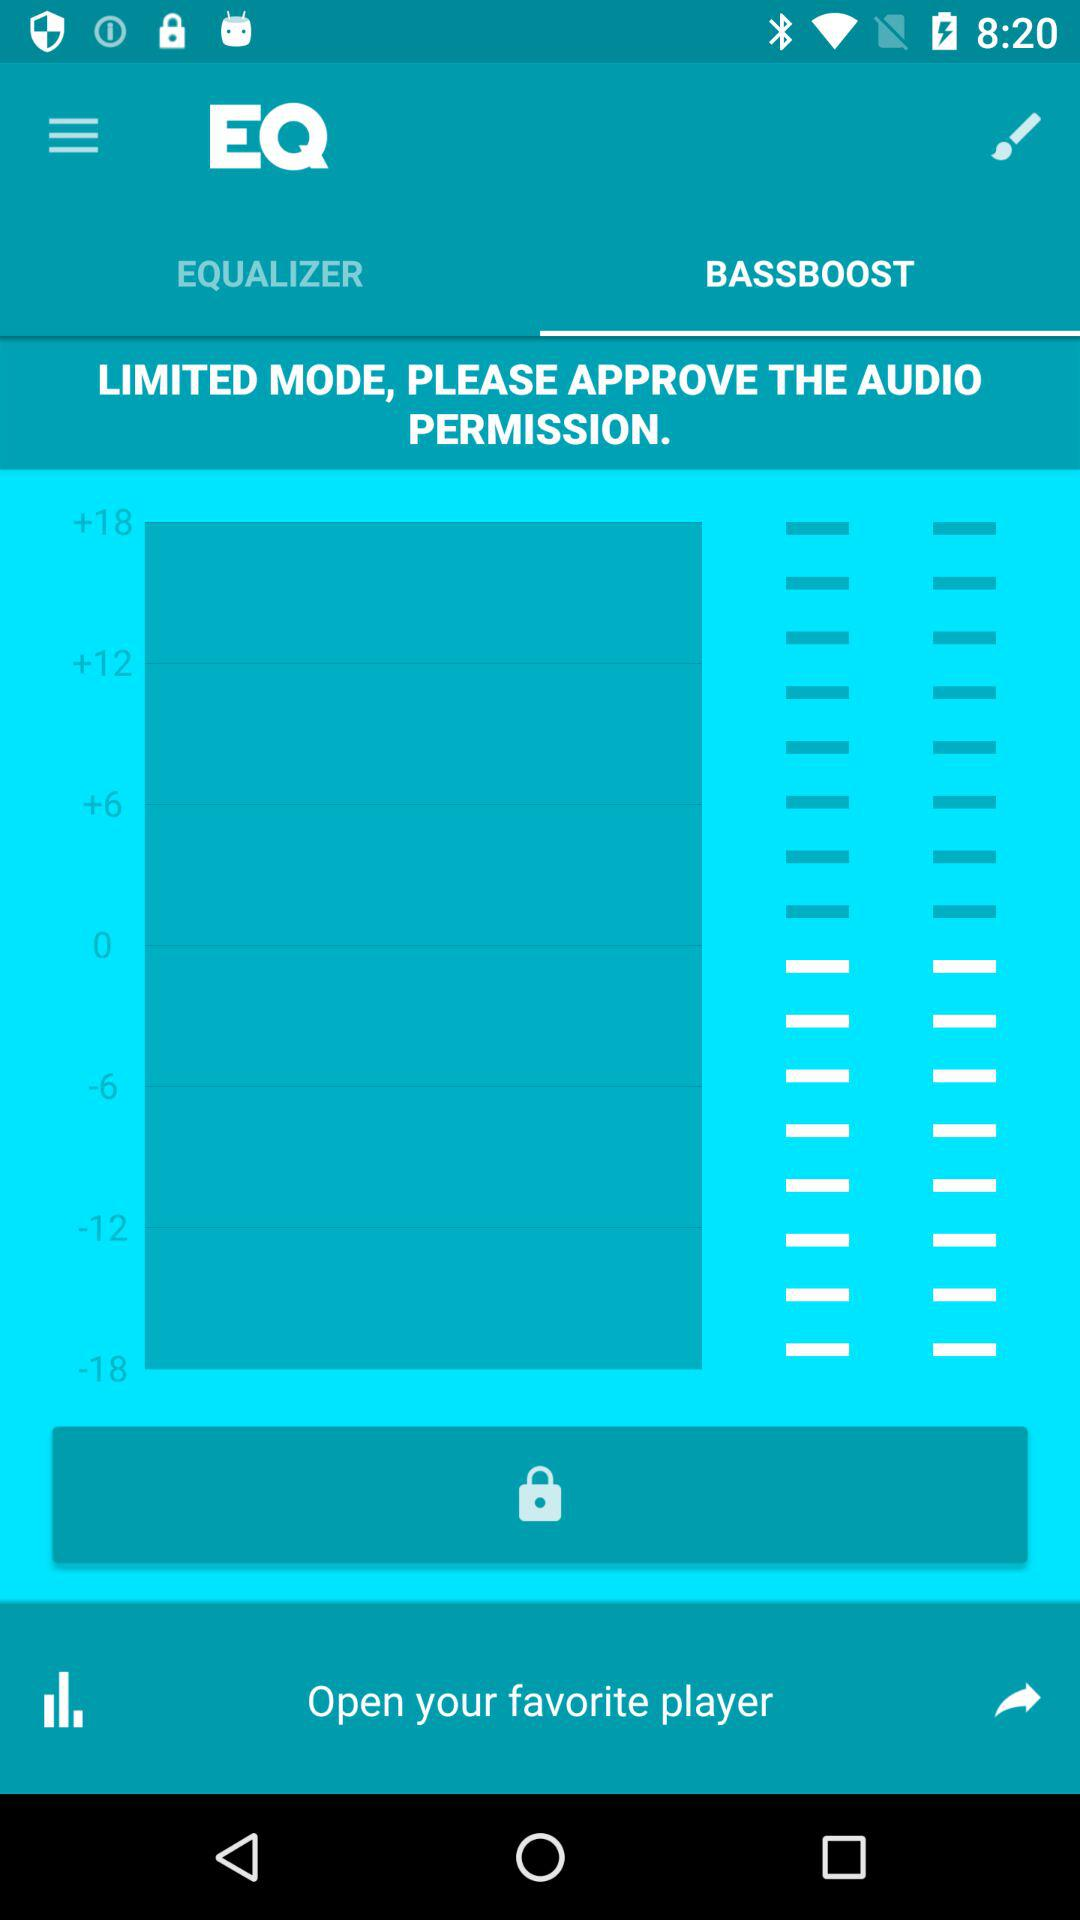What is the application name? The application is "EQ". 